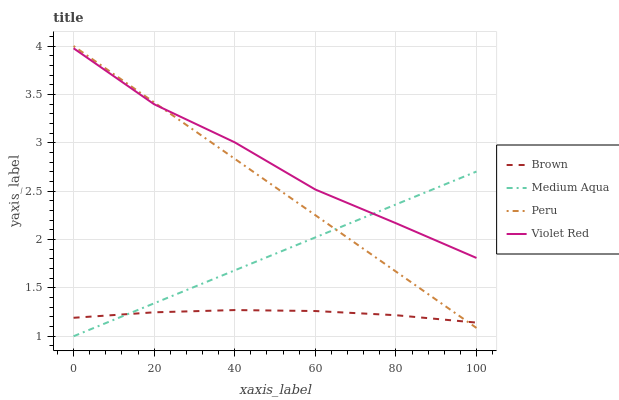Does Brown have the minimum area under the curve?
Answer yes or no. Yes. Does Violet Red have the maximum area under the curve?
Answer yes or no. Yes. Does Medium Aqua have the minimum area under the curve?
Answer yes or no. No. Does Medium Aqua have the maximum area under the curve?
Answer yes or no. No. Is Medium Aqua the smoothest?
Answer yes or no. Yes. Is Violet Red the roughest?
Answer yes or no. Yes. Is Violet Red the smoothest?
Answer yes or no. No. Is Medium Aqua the roughest?
Answer yes or no. No. Does Medium Aqua have the lowest value?
Answer yes or no. Yes. Does Violet Red have the lowest value?
Answer yes or no. No. Does Peru have the highest value?
Answer yes or no. Yes. Does Violet Red have the highest value?
Answer yes or no. No. Is Brown less than Violet Red?
Answer yes or no. Yes. Is Violet Red greater than Brown?
Answer yes or no. Yes. Does Brown intersect Medium Aqua?
Answer yes or no. Yes. Is Brown less than Medium Aqua?
Answer yes or no. No. Is Brown greater than Medium Aqua?
Answer yes or no. No. Does Brown intersect Violet Red?
Answer yes or no. No. 